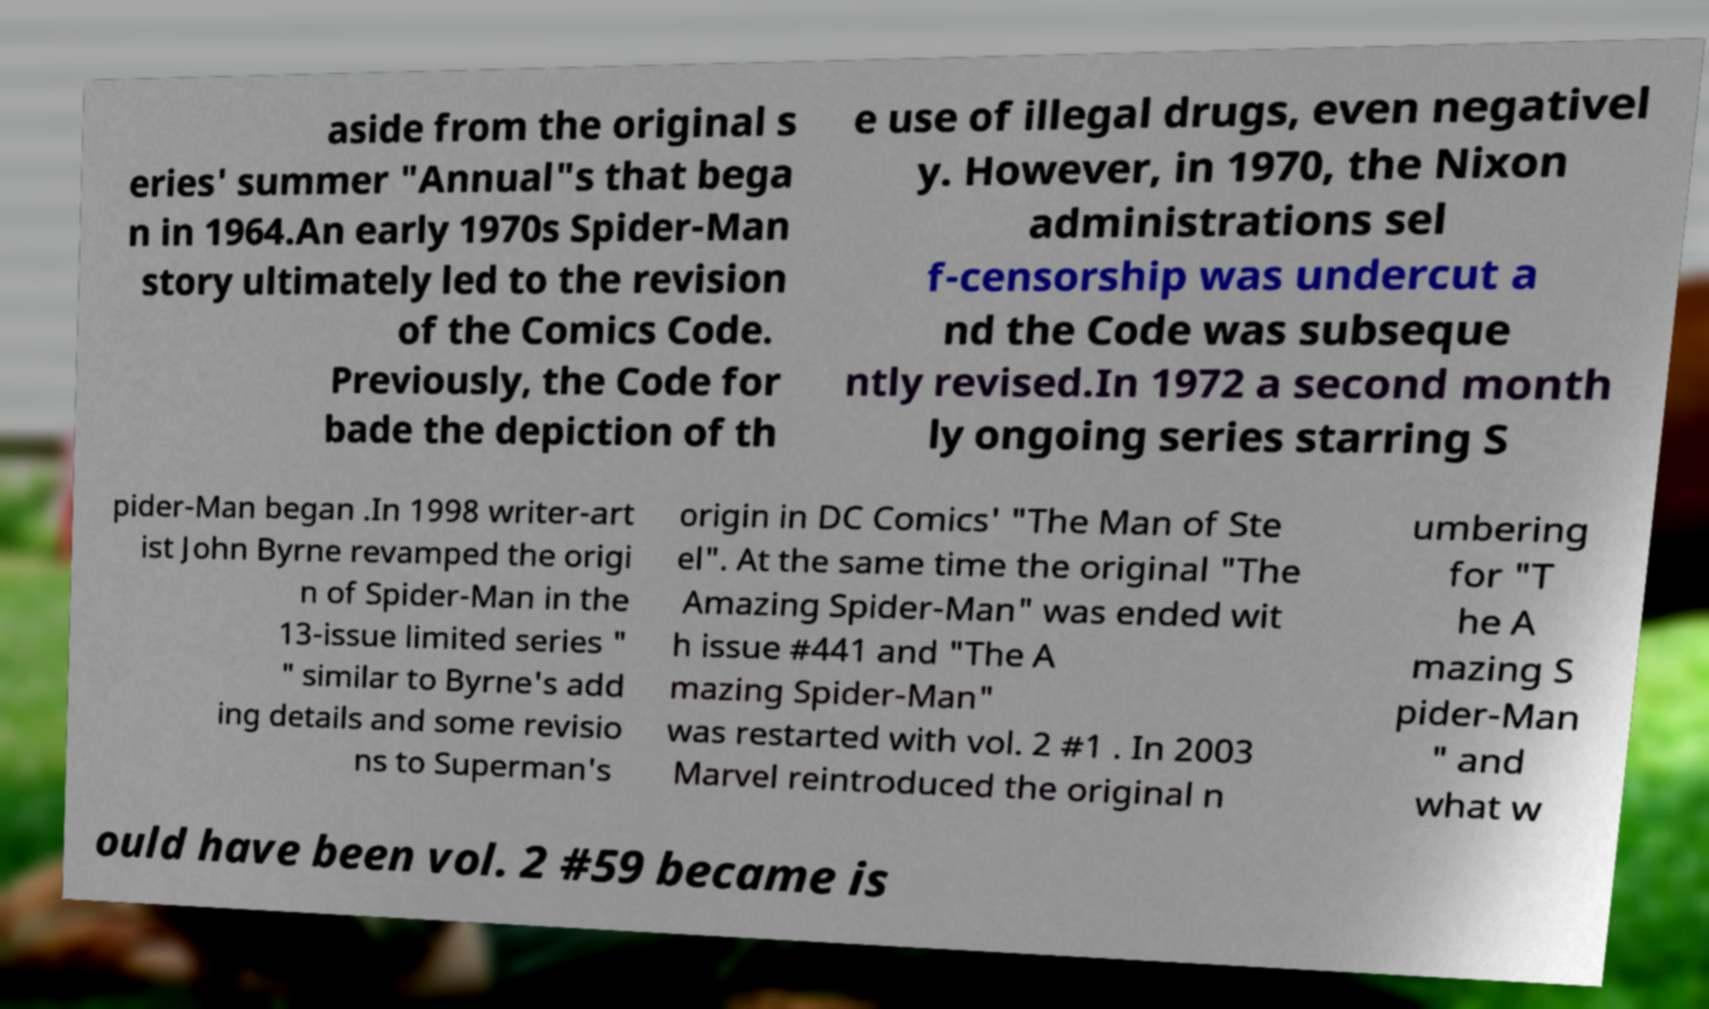There's text embedded in this image that I need extracted. Can you transcribe it verbatim? aside from the original s eries' summer "Annual"s that bega n in 1964.An early 1970s Spider-Man story ultimately led to the revision of the Comics Code. Previously, the Code for bade the depiction of th e use of illegal drugs, even negativel y. However, in 1970, the Nixon administrations sel f-censorship was undercut a nd the Code was subseque ntly revised.In 1972 a second month ly ongoing series starring S pider-Man began .In 1998 writer-art ist John Byrne revamped the origi n of Spider-Man in the 13-issue limited series " " similar to Byrne's add ing details and some revisio ns to Superman's origin in DC Comics' "The Man of Ste el". At the same time the original "The Amazing Spider-Man" was ended wit h issue #441 and "The A mazing Spider-Man" was restarted with vol. 2 #1 . In 2003 Marvel reintroduced the original n umbering for "T he A mazing S pider-Man " and what w ould have been vol. 2 #59 became is 